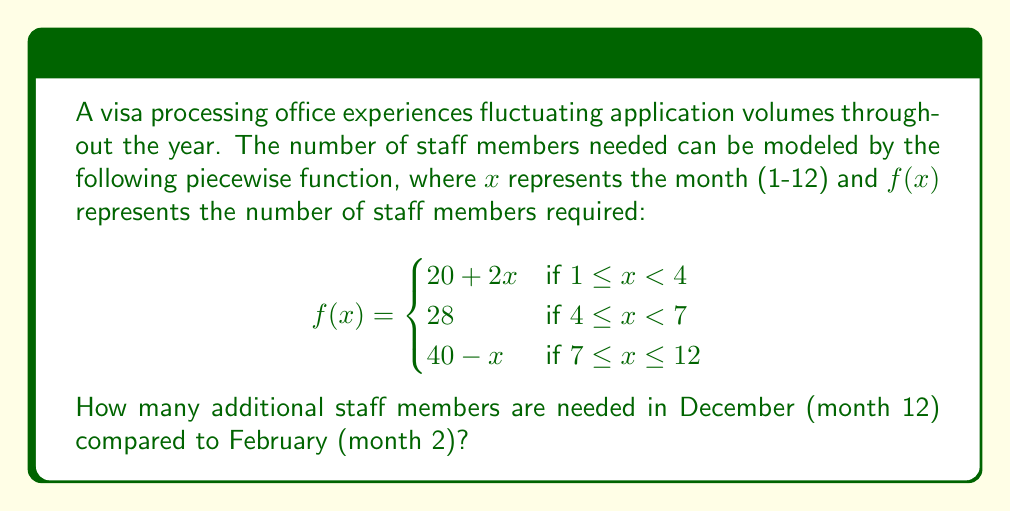Give your solution to this math problem. To solve this problem, we need to calculate the number of staff members required for both February and December, then find the difference.

Step 1: Calculate staff needed for February (x = 2)
February is month 2, so we use the first piece of the function:
$f(2) = 20 + 2(2) = 20 + 4 = 24$ staff members

Step 2: Calculate staff needed for December (x = 12)
December is month 12, so we use the third piece of the function:
$f(12) = 40 - 12 = 28$ staff members

Step 3: Calculate the difference
Additional staff needed in December compared to February:
$28 - 24 = 4$ staff members

Therefore, 4 additional staff members are needed in December compared to February.
Answer: 4 